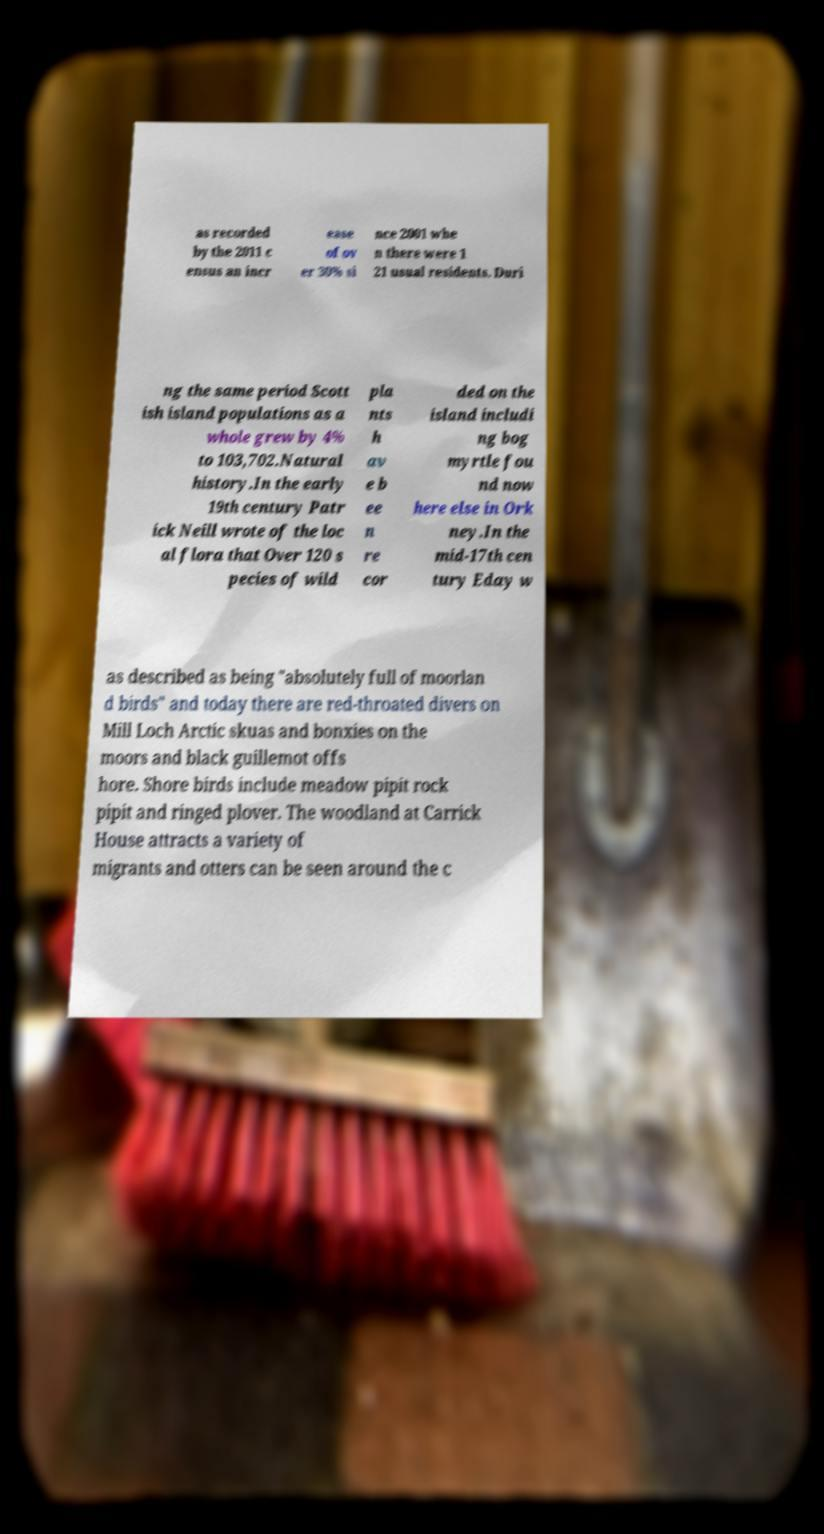Please identify and transcribe the text found in this image. as recorded by the 2011 c ensus an incr ease of ov er 30% si nce 2001 whe n there were 1 21 usual residents. Duri ng the same period Scott ish island populations as a whole grew by 4% to 103,702.Natural history.In the early 19th century Patr ick Neill wrote of the loc al flora that Over 120 s pecies of wild pla nts h av e b ee n re cor ded on the island includi ng bog myrtle fou nd now here else in Ork ney.In the mid-17th cen tury Eday w as described as being "absolutely full of moorlan d birds" and today there are red-throated divers on Mill Loch Arctic skuas and bonxies on the moors and black guillemot offs hore. Shore birds include meadow pipit rock pipit and ringed plover. The woodland at Carrick House attracts a variety of migrants and otters can be seen around the c 